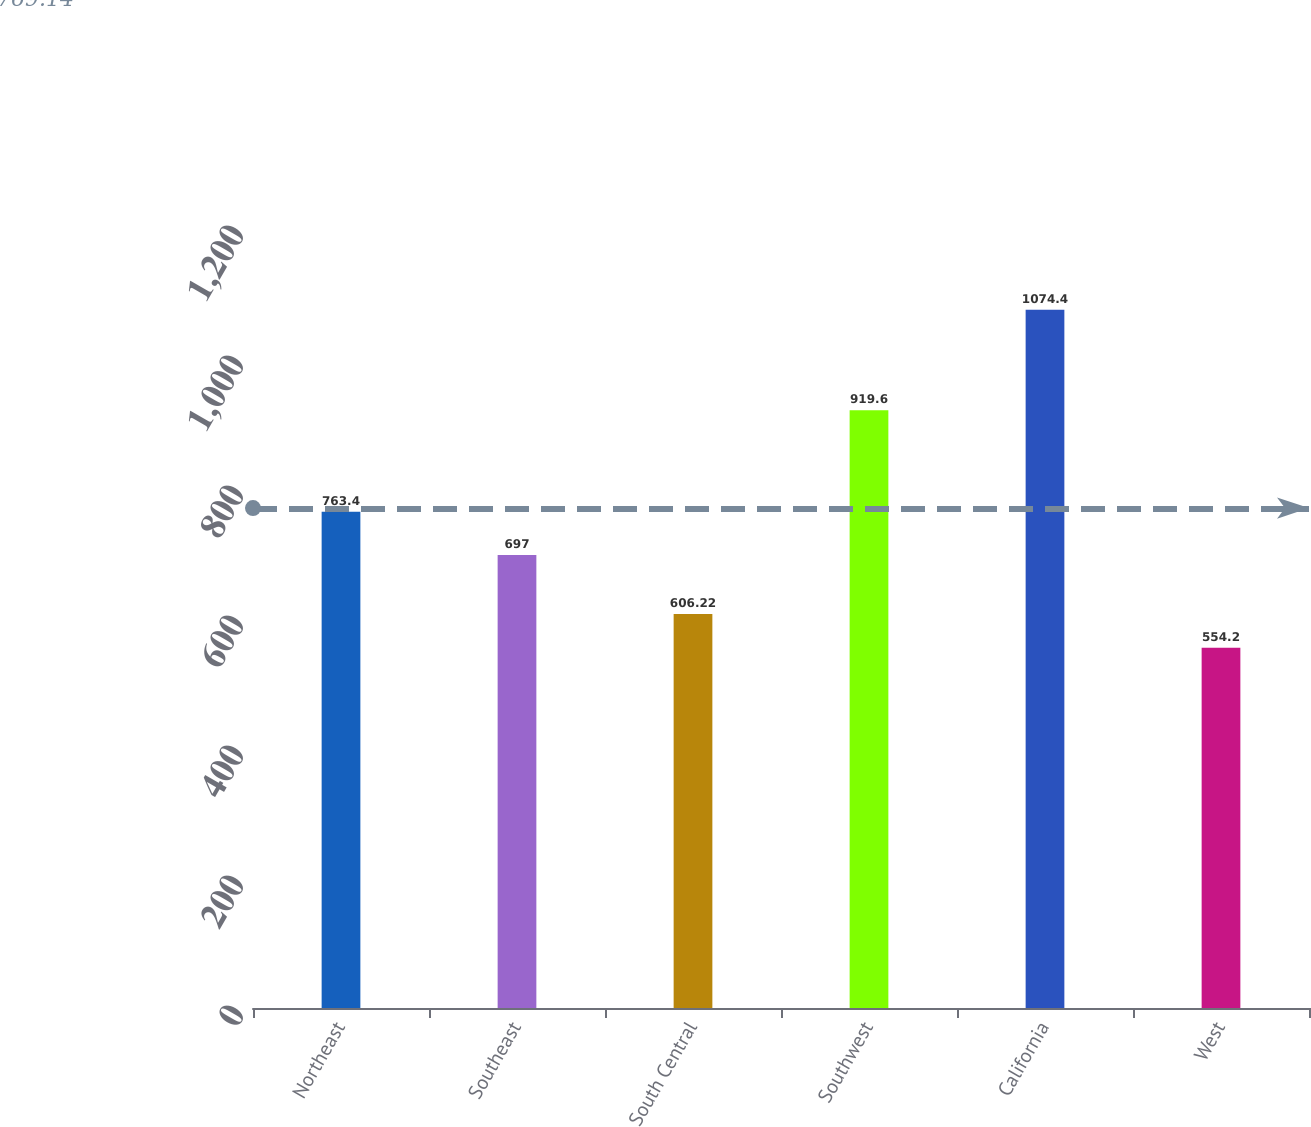Convert chart. <chart><loc_0><loc_0><loc_500><loc_500><bar_chart><fcel>Northeast<fcel>Southeast<fcel>South Central<fcel>Southwest<fcel>California<fcel>West<nl><fcel>763.4<fcel>697<fcel>606.22<fcel>919.6<fcel>1074.4<fcel>554.2<nl></chart> 